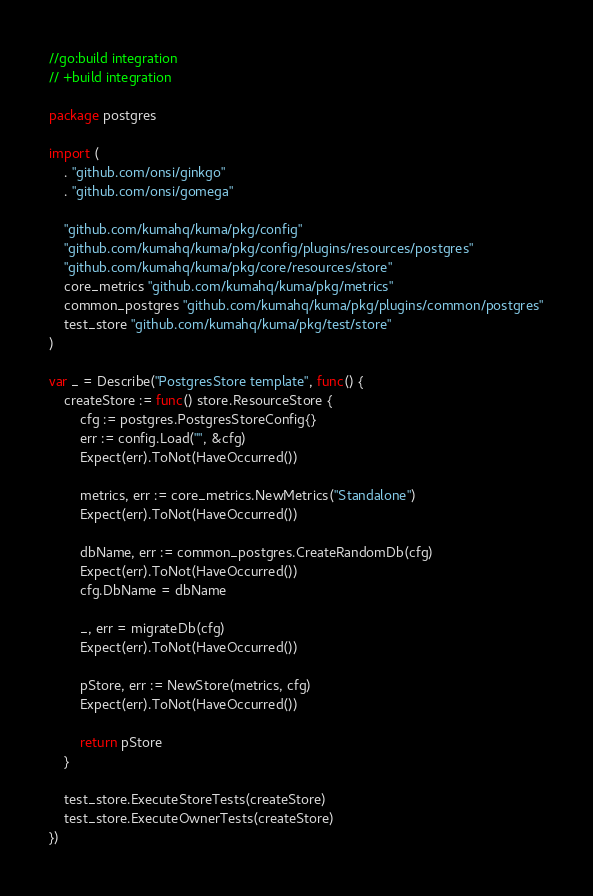Convert code to text. <code><loc_0><loc_0><loc_500><loc_500><_Go_>//go:build integration
// +build integration

package postgres

import (
	. "github.com/onsi/ginkgo"
	. "github.com/onsi/gomega"

	"github.com/kumahq/kuma/pkg/config"
	"github.com/kumahq/kuma/pkg/config/plugins/resources/postgres"
	"github.com/kumahq/kuma/pkg/core/resources/store"
	core_metrics "github.com/kumahq/kuma/pkg/metrics"
	common_postgres "github.com/kumahq/kuma/pkg/plugins/common/postgres"
	test_store "github.com/kumahq/kuma/pkg/test/store"
)

var _ = Describe("PostgresStore template", func() {
	createStore := func() store.ResourceStore {
		cfg := postgres.PostgresStoreConfig{}
		err := config.Load("", &cfg)
		Expect(err).ToNot(HaveOccurred())

		metrics, err := core_metrics.NewMetrics("Standalone")
		Expect(err).ToNot(HaveOccurred())

		dbName, err := common_postgres.CreateRandomDb(cfg)
		Expect(err).ToNot(HaveOccurred())
		cfg.DbName = dbName

		_, err = migrateDb(cfg)
		Expect(err).ToNot(HaveOccurred())

		pStore, err := NewStore(metrics, cfg)
		Expect(err).ToNot(HaveOccurred())

		return pStore
	}

	test_store.ExecuteStoreTests(createStore)
	test_store.ExecuteOwnerTests(createStore)
})
</code> 